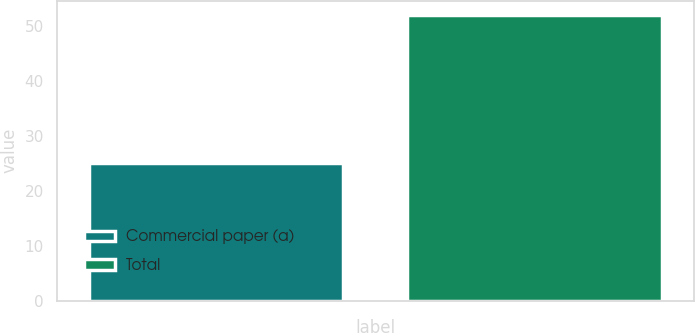Convert chart. <chart><loc_0><loc_0><loc_500><loc_500><bar_chart><fcel>Commercial paper (a)<fcel>Total<nl><fcel>25<fcel>52<nl></chart> 